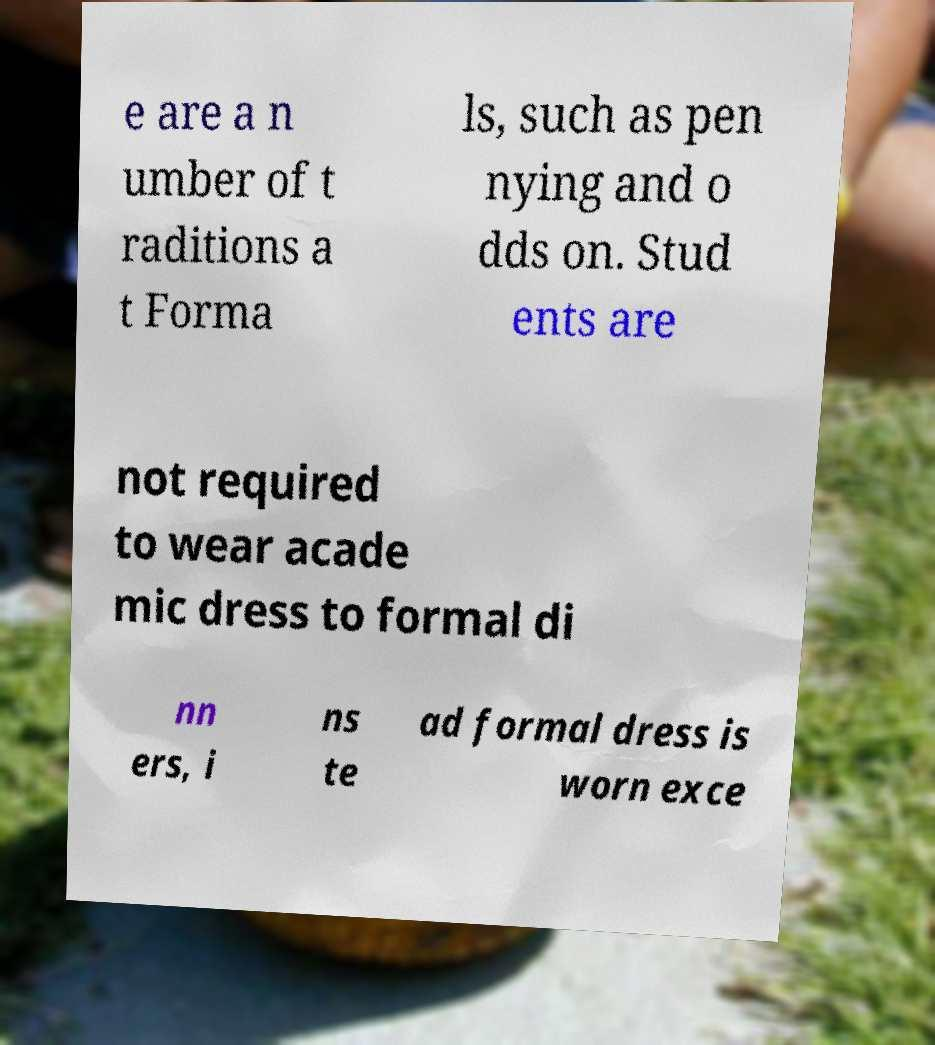Could you assist in decoding the text presented in this image and type it out clearly? e are a n umber of t raditions a t Forma ls, such as pen nying and o dds on. Stud ents are not required to wear acade mic dress to formal di nn ers, i ns te ad formal dress is worn exce 